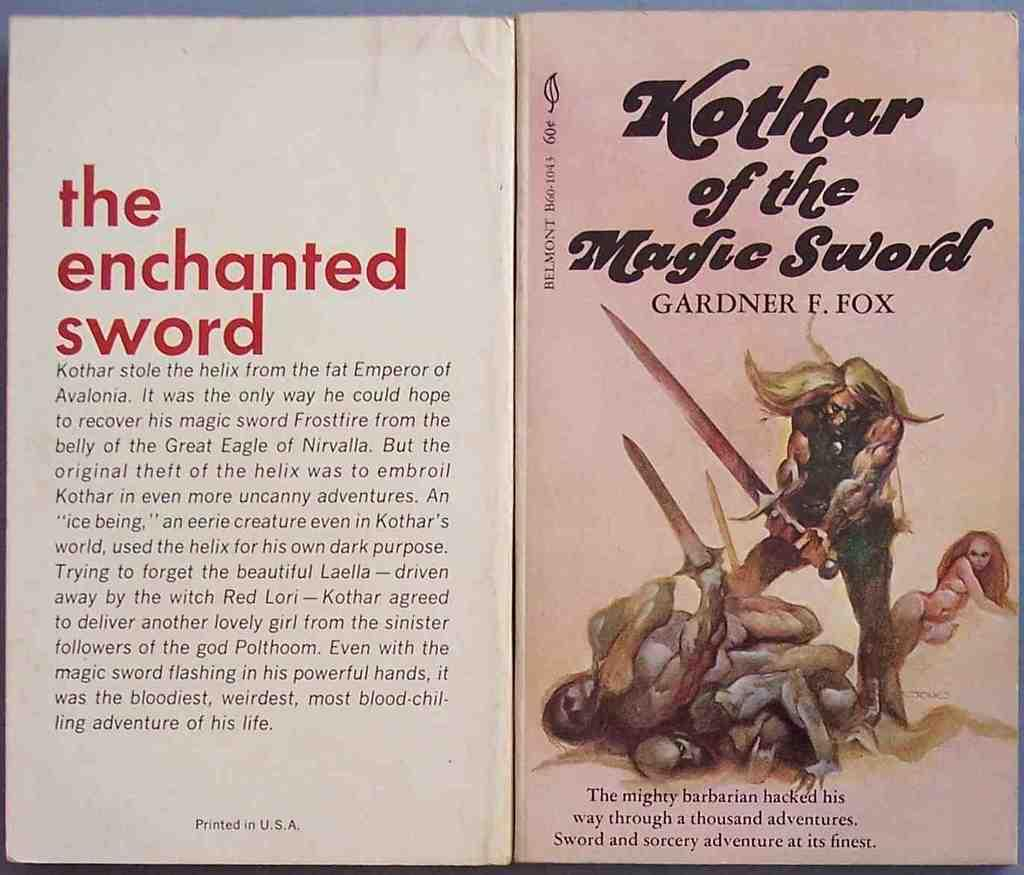<image>
Provide a brief description of the given image. A book titled Kothar of the Magic Sword by Gardner Fox. 